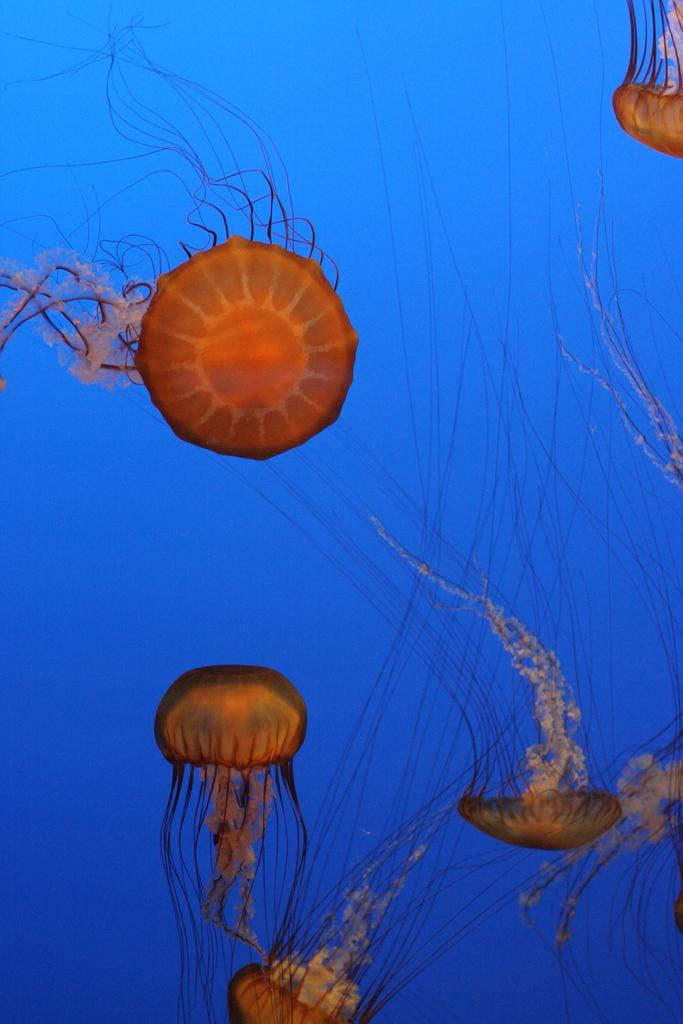What type of animals are in the image? There are jelly fishes in the image. What are the jelly fishes doing in the image? The jelly fishes are swimming in the water. What type of doll is sitting on the drain in the image? There is no doll or drain present in the image; it features jelly fishes swimming in the water. 